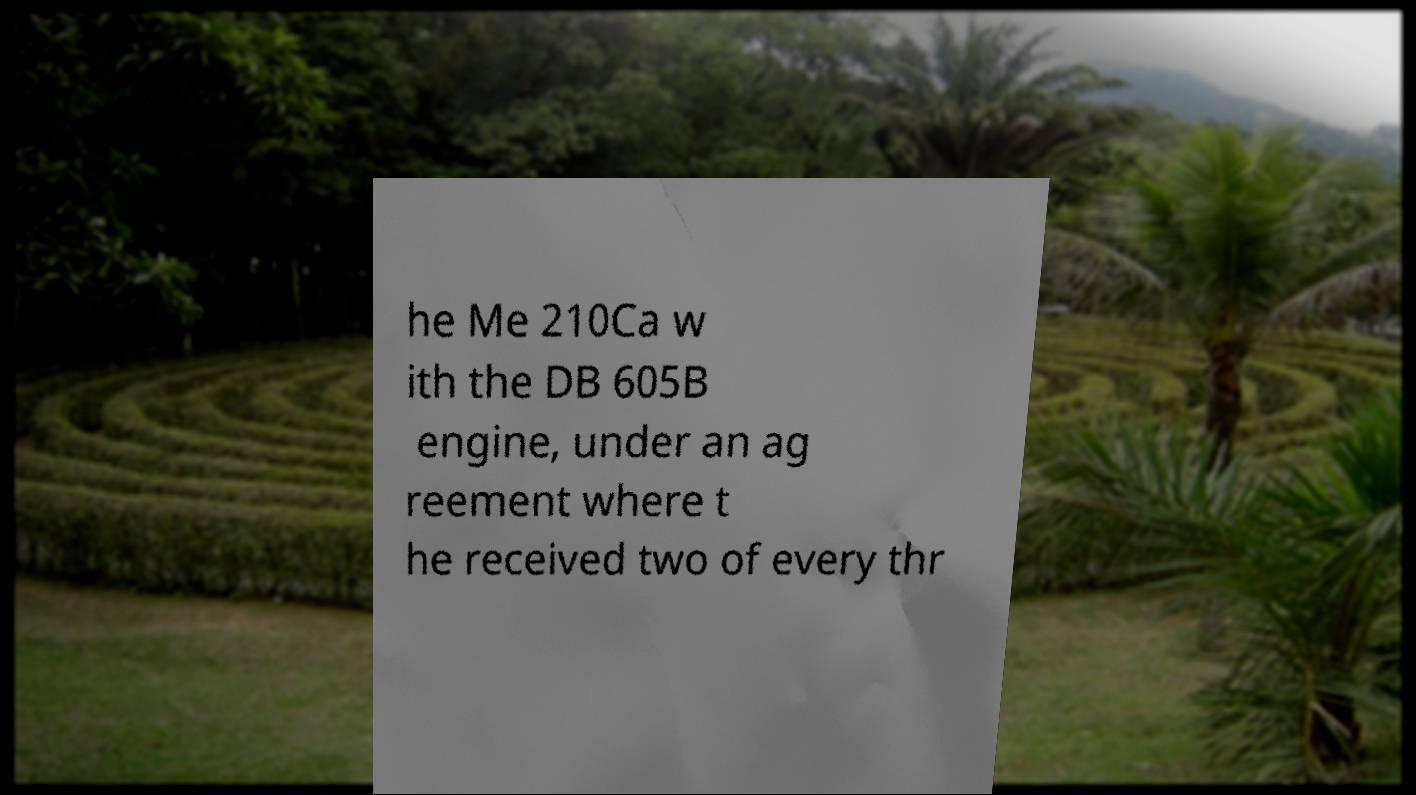What messages or text are displayed in this image? I need them in a readable, typed format. he Me 210Ca w ith the DB 605B engine, under an ag reement where t he received two of every thr 